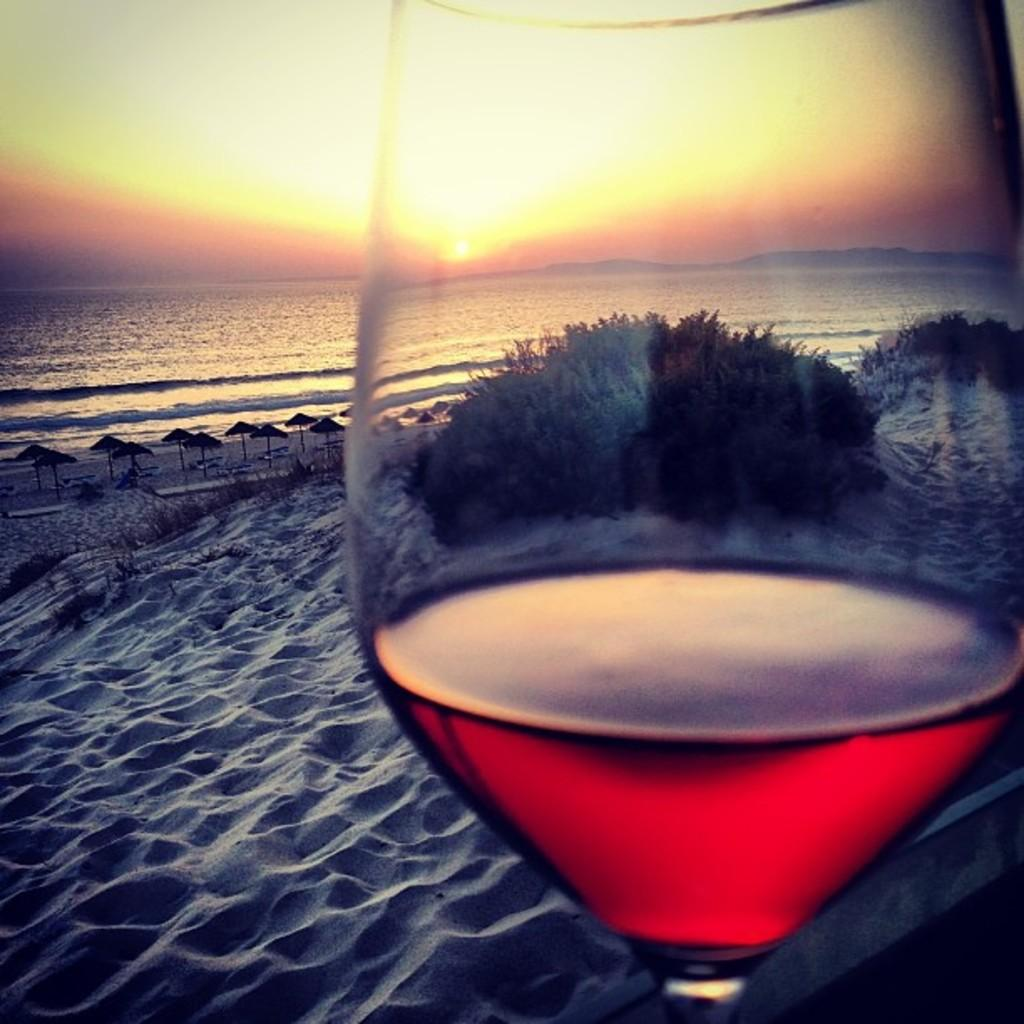What type of glass is present in the image? There is a wine glass in the image. What color is the wine in the glass? The wine in the glass is red. What type of terrain can be seen in the background of the image? There is sand visible in the background of the image. What objects are present in the background of the image? There are umbrellas and water visible in the background of the image. What is visible in the sky in the image? The sky is visible in the background of the image, and the sun is observable. What type of calculator is present in the image? There is no calculator present in the image. What type of flower can be seen growing in the sand in the image? There is no flower visible in the image; only sand, umbrellas, water, and the sky are present. 